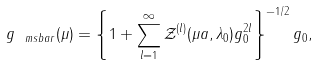<formula> <loc_0><loc_0><loc_500><loc_500>g _ { \ m s b a r } ( \mu ) = \left \{ 1 + \sum _ { l = 1 } ^ { \infty } { \mathcal { Z } } ^ { ( l ) } ( \mu a , \lambda _ { 0 } ) g _ { 0 } ^ { 2 l } \right \} ^ { - 1 / 2 } g _ { 0 } ,</formula> 